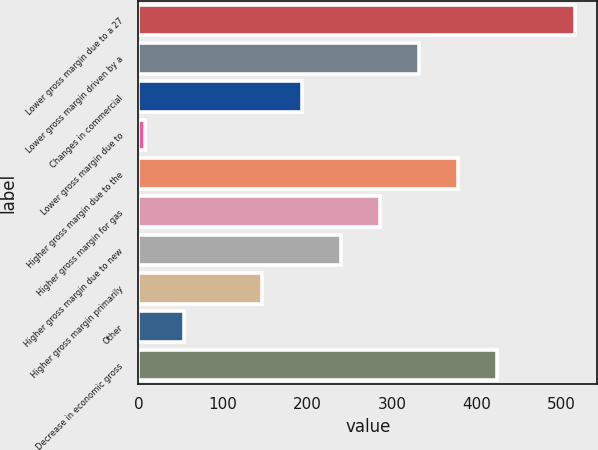Convert chart. <chart><loc_0><loc_0><loc_500><loc_500><bar_chart><fcel>Lower gross margin due to a 27<fcel>Lower gross margin driven by a<fcel>Changes in commercial<fcel>Lower gross margin due to<fcel>Higher gross margin due to the<fcel>Higher gross margin for gas<fcel>Higher gross margin due to new<fcel>Higher gross margin primarily<fcel>Other<fcel>Decrease in economic gross<nl><fcel>516.2<fcel>331.4<fcel>192.8<fcel>8<fcel>377.6<fcel>285.2<fcel>239<fcel>146.6<fcel>54.2<fcel>423.8<nl></chart> 